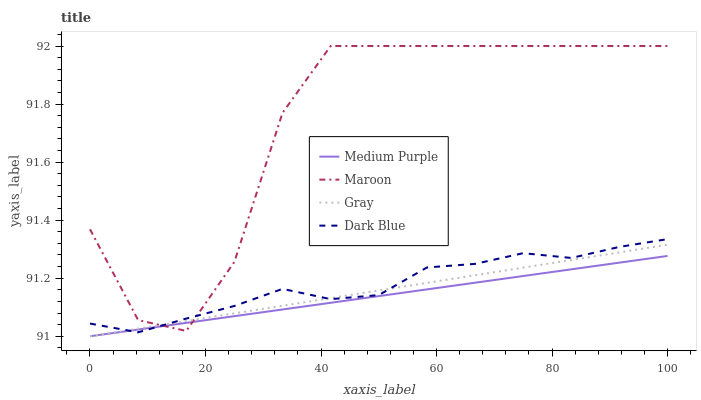Does Medium Purple have the minimum area under the curve?
Answer yes or no. Yes. Does Maroon have the maximum area under the curve?
Answer yes or no. Yes. Does Gray have the minimum area under the curve?
Answer yes or no. No. Does Gray have the maximum area under the curve?
Answer yes or no. No. Is Gray the smoothest?
Answer yes or no. Yes. Is Maroon the roughest?
Answer yes or no. Yes. Is Maroon the smoothest?
Answer yes or no. No. Is Gray the roughest?
Answer yes or no. No. Does Medium Purple have the lowest value?
Answer yes or no. Yes. Does Maroon have the lowest value?
Answer yes or no. No. Does Maroon have the highest value?
Answer yes or no. Yes. Does Gray have the highest value?
Answer yes or no. No. Does Dark Blue intersect Gray?
Answer yes or no. Yes. Is Dark Blue less than Gray?
Answer yes or no. No. Is Dark Blue greater than Gray?
Answer yes or no. No. 